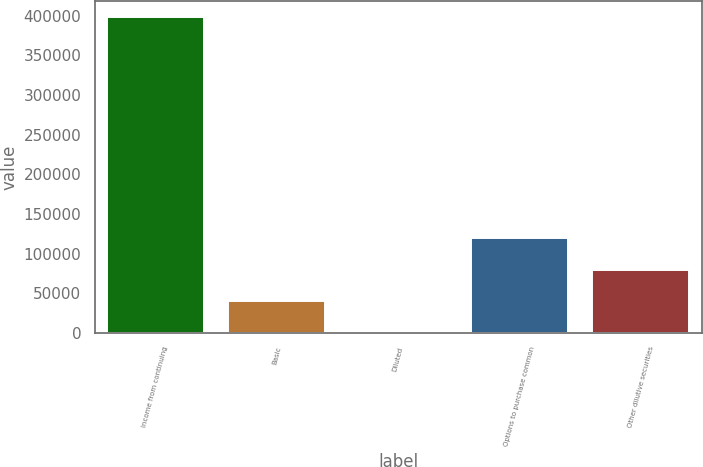Convert chart to OTSL. <chart><loc_0><loc_0><loc_500><loc_500><bar_chart><fcel>Income from continuing<fcel>Basic<fcel>Diluted<fcel>Options to purchase common<fcel>Other dilutive securities<nl><fcel>398097<fcel>39812.4<fcel>2.99<fcel>119431<fcel>79621.8<nl></chart> 